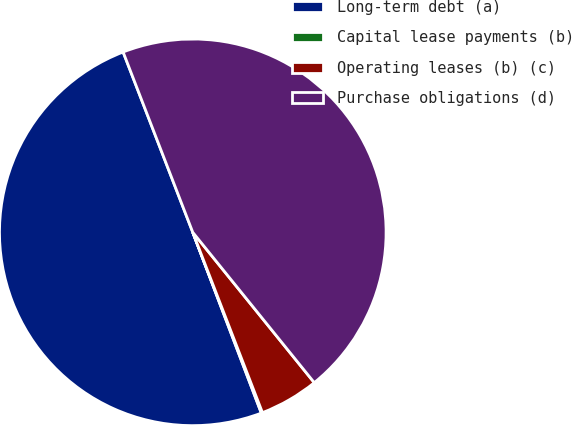Convert chart to OTSL. <chart><loc_0><loc_0><loc_500><loc_500><pie_chart><fcel>Long-term debt (a)<fcel>Capital lease payments (b)<fcel>Operating leases (b) (c)<fcel>Purchase obligations (d)<nl><fcel>49.9%<fcel>0.1%<fcel>4.95%<fcel>45.05%<nl></chart> 